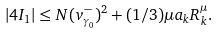Convert formula to latex. <formula><loc_0><loc_0><loc_500><loc_500>| 4 I _ { 1 } | \leq N ( v _ { \gamma _ { 0 } } ^ { - } ) ^ { 2 } + ( 1 / 3 ) \mu a _ { k } R ^ { \mu } _ { k } .</formula> 